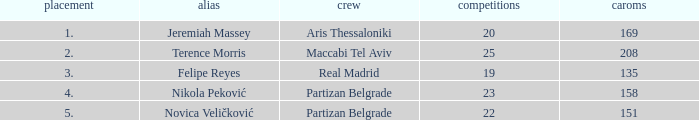How many Games for Terence Morris? 25.0. 